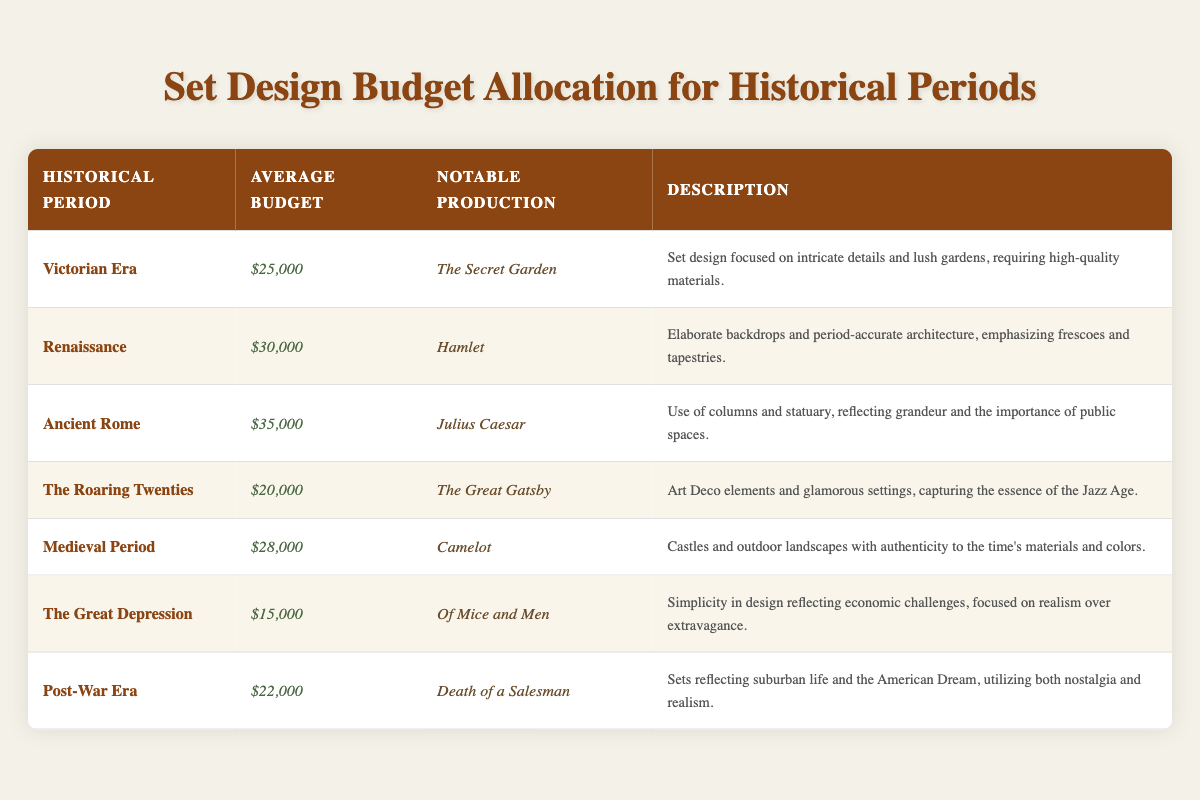What is the average budget for set design in the Victorian Era? The table lists the average budget for the Victorian Era as $25,000.
Answer: $25,000 Which production has the highest average budget? The table shows that the average budget for Ancient Rome is $35,000, which is the highest compared to other periods.
Answer: Julius Caesar Did the set design for The Great Depression have a higher budget than the Medieval Period? The budget for The Great Depression is $15,000, while the Medieval Period is $28,000. Since $15,000 is less than $28,000, the answer is no.
Answer: No How much higher is the average budget for the Renaissance compared to the Roaring Twenties? The Renaissance budget is $30,000 and the Roaring Twenties is $20,000. The difference is calculated as $30,000 - $20,000 = $10,000.
Answer: $10,000 List the average budgets for the two periods that have budgets over $25,000. Looking at the table, the periods with budgets over $25,000 are Renaissance ($30,000) and Ancient Rome ($35,000).
Answer: $30,000 and $35,000 Is the notable production for the Medieval Period "Camelot"? Referring to the table, it shows that the notable production for the Medieval Period is indeed "Camelot". Thus, the answer is yes.
Answer: Yes What is the total average budget allocated for set design across all listed historical periods? To find the total, sum the budgets: $25,000 (Victorian) + $30,000 (Renaissance) + $35,000 (Ancient Rome) + $20,000 (The Roaring Twenties) + $28,000 (Medieval) + $15,000 (The Great Depression) + $22,000 (Post-War) = $175,000.
Answer: $175,000 How does the budget for the Post-War Era compare to the average for the Great Depression? The budget for the Post-War Era is $22,000 and for the Great Depression, it is $15,000. The Post-War Era budget is higher by $22,000 - $15,000 = $7,000.
Answer: $7,000 Which historical period had the lowest budget, and what was it? The Great Depression had the lowest average budget at $15,000 as per the table.
Answer: The Great Depression, $15,000 What is the combined average budget of productions from the Victorian Era and the Renaissance? The combined average budget is $25,000 (Victorian) + $30,000 (Renaissance) = $55,000.
Answer: $55,000 Is the description for Ancient Rome focused on simplicity? The table indicates that the description for Ancient Rome includes grandeur and columns, so it does not focus on simplicity. Therefore, the answer is no.
Answer: No 